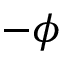Convert formula to latex. <formula><loc_0><loc_0><loc_500><loc_500>- \phi</formula> 